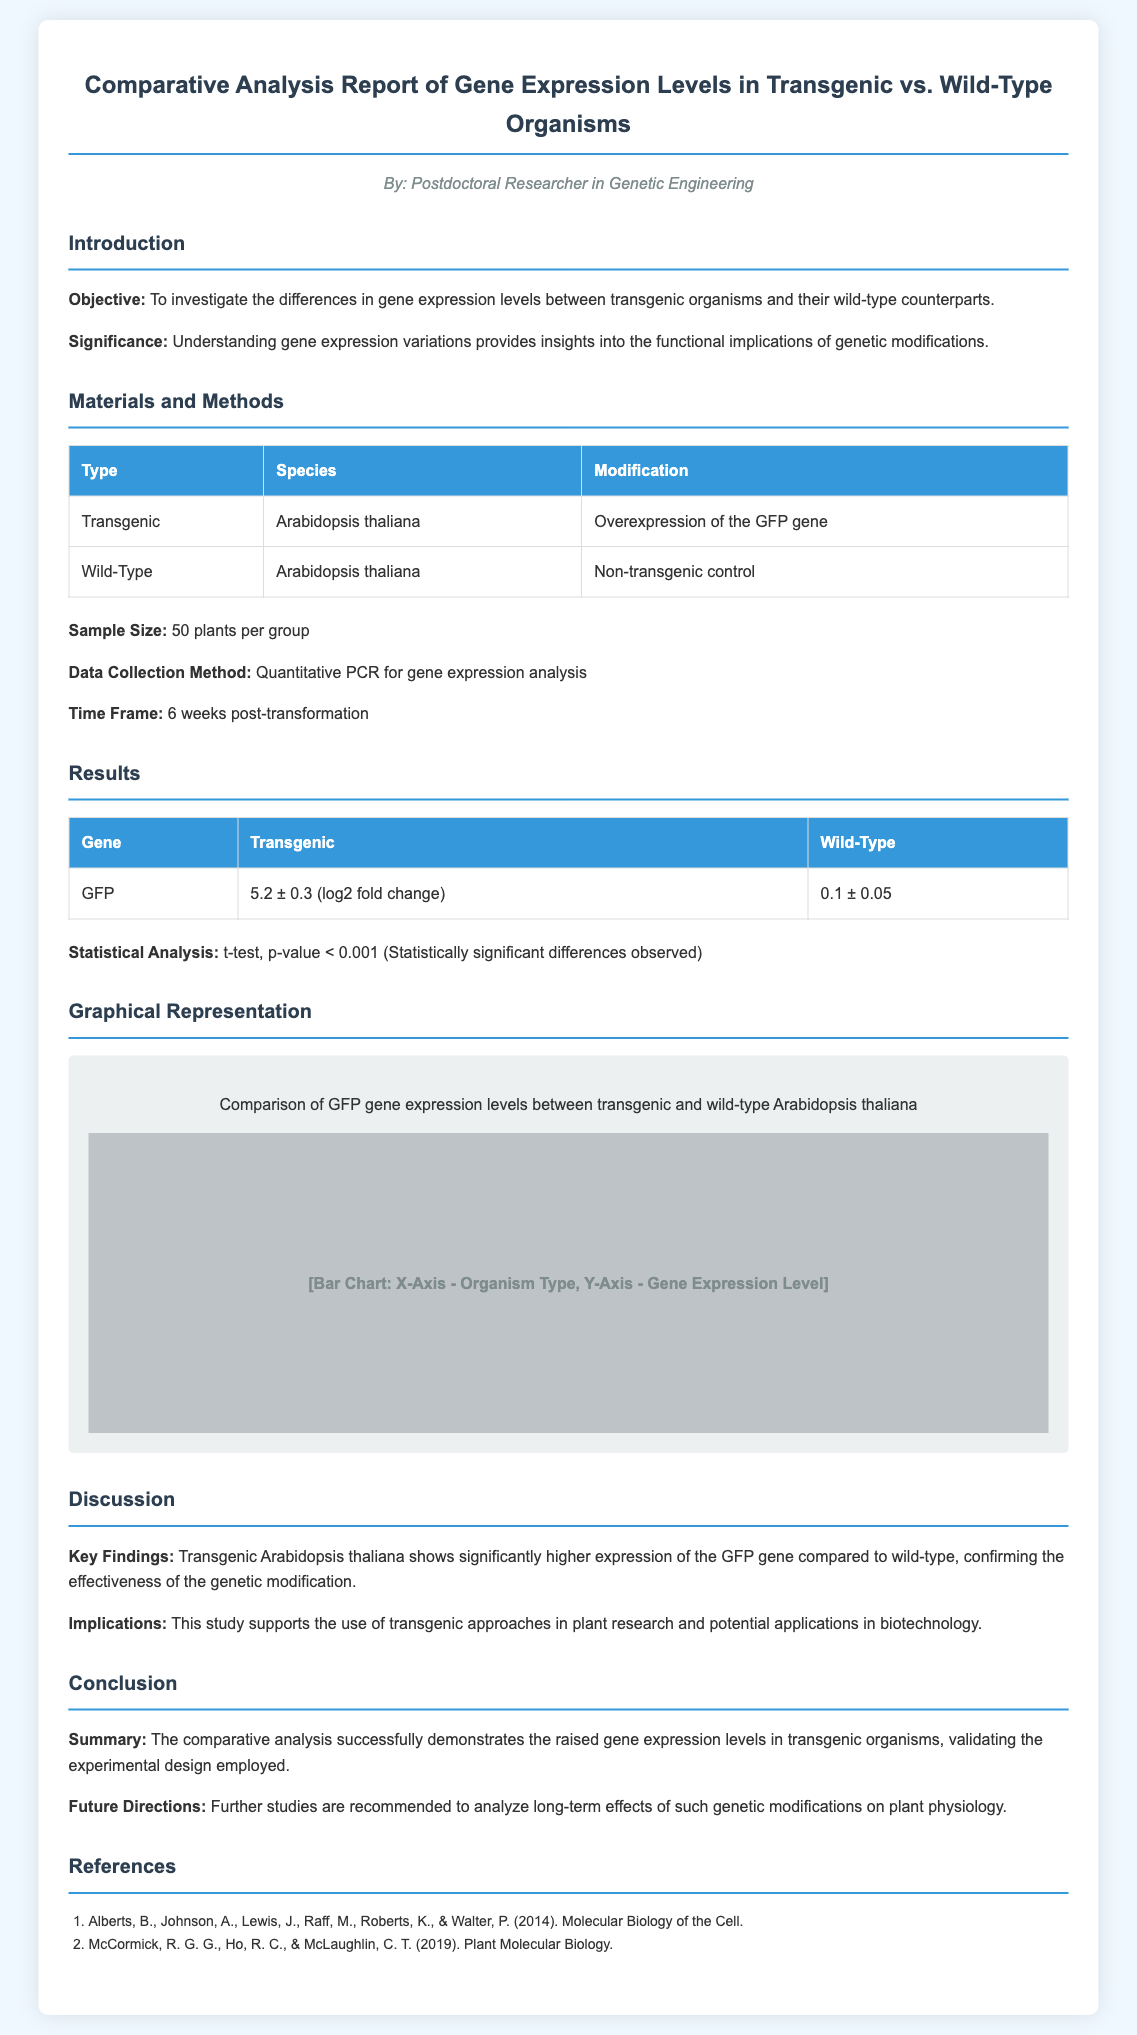What is the objective of the study? The objective is outlined in the introduction section, which states it is to investigate the differences in gene expression levels between transgenic organisms and their wild-type counterparts.
Answer: Investigate differences in gene expression levels What species was used for the transgenic organism? The materials and methods section lists Arabidopsis thaliana as the species for the transgenic organism.
Answer: Arabidopsis thaliana What was the sample size for each group? The materials and methods section specifies that the sample size was 50 plants per group.
Answer: 50 plants What gene's expression level was compared? The results section indicates that the gene being analyzed is the GFP gene.
Answer: GFP What was the t-test p-value result? The results section provides the statistical analysis result that the p-value is less than 0.001, indicating significant differences.
Answer: Less than 0.001 What conclusion is drawn about transgenic Arabidopsis thaliana? The discussion section states that transgenic Arabidopsis thaliana shows significantly higher expression of the GFP gene compared to wild-type.
Answer: Higher expression of GFP gene What future direction is recommended in the conclusion? The conclusion suggests further studies to analyze the long-term effects of genetic modifications on plant physiology.
Answer: Analyze long-term effects What does the graphical representation illustrate? The graphical representation section describes it as a comparison of GFP gene expression levels between transgenic and wild-type Arabidopsis thaliana.
Answer: Comparison of GFP gene expression levels Who is the author of the report? The author is mentioned at the beginning of the document, which states the author is a Postdoctoral Researcher in Genetic Engineering.
Answer: Postdoctoral Researcher in Genetic Engineering 